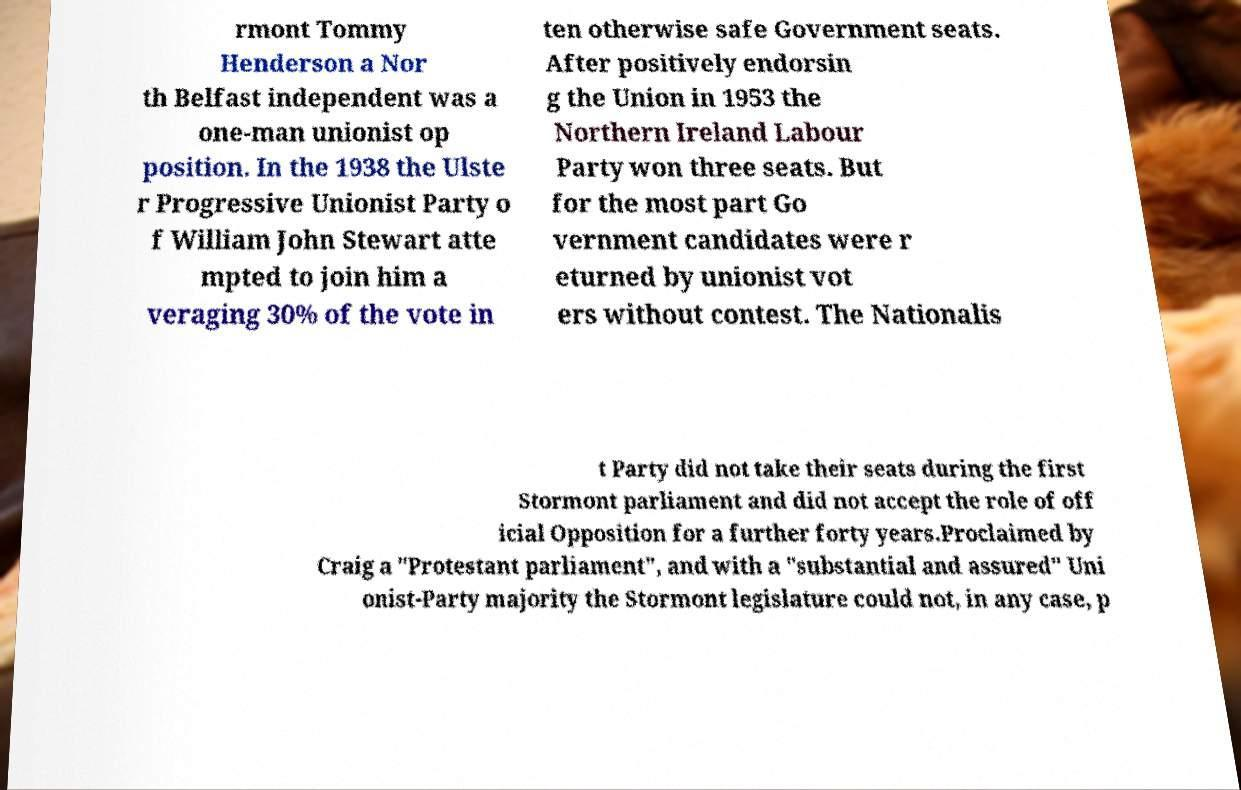Can you accurately transcribe the text from the provided image for me? rmont Tommy Henderson a Nor th Belfast independent was a one-man unionist op position. In the 1938 the Ulste r Progressive Unionist Party o f William John Stewart atte mpted to join him a veraging 30% of the vote in ten otherwise safe Government seats. After positively endorsin g the Union in 1953 the Northern Ireland Labour Party won three seats. But for the most part Go vernment candidates were r eturned by unionist vot ers without contest. The Nationalis t Party did not take their seats during the first Stormont parliament and did not accept the role of off icial Opposition for a further forty years.Proclaimed by Craig a "Protestant parliament", and with a "substantial and assured" Uni onist-Party majority the Stormont legislature could not, in any case, p 